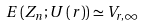Convert formula to latex. <formula><loc_0><loc_0><loc_500><loc_500>E \left ( Z _ { n } ; U \left ( r \right ) \right ) \simeq V _ { r , \infty }</formula> 